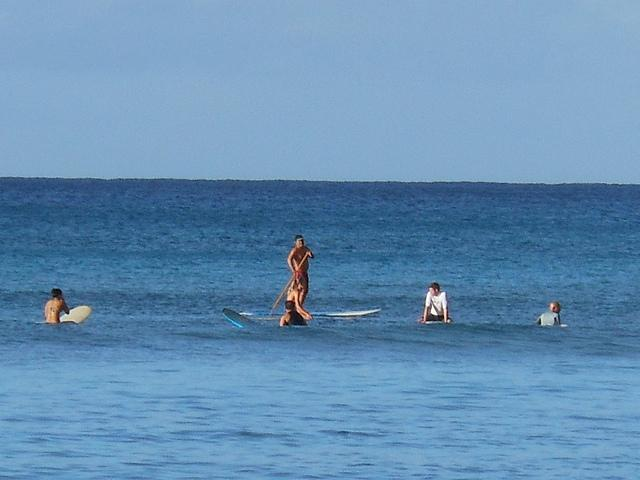What is the man who is standing doing? paddling 